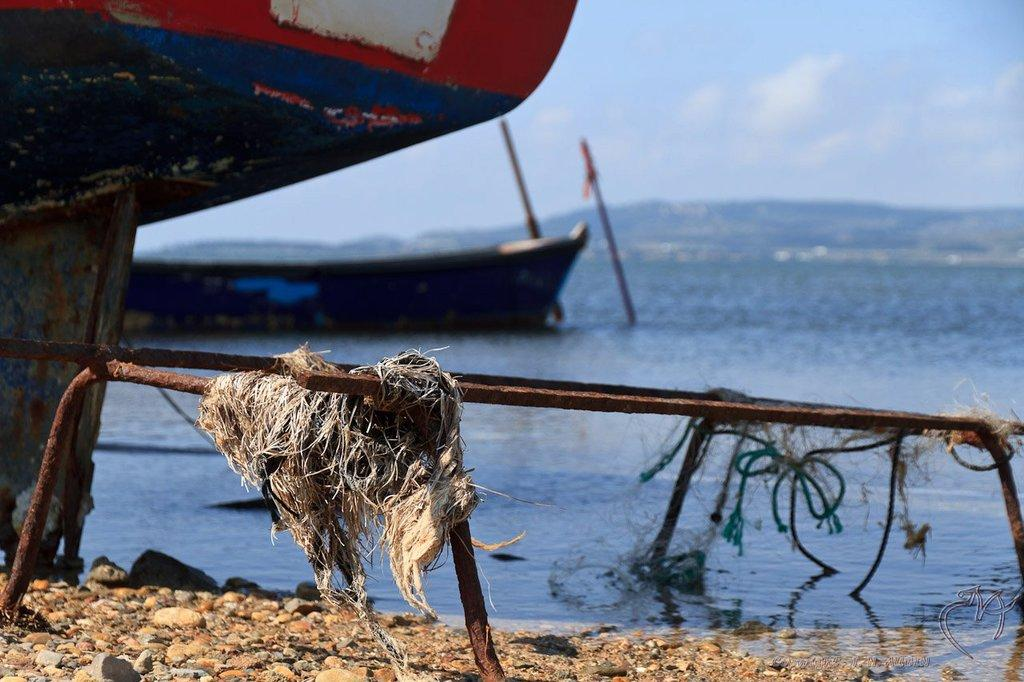What type of surface is visible in the image? There are roads on the surface in the image. What type of natural elements can be seen in the image? Stones are visible in the image. What is the boat's position in relation to the water in the image? The boat is above the water in the image. What other objects are present in the image? Sticks are present in the image. What can be seen in the background of the image? The sky is visible in the background of the image. What is the weather like in the image? Clouds are present in the sky, indicating that it might be a partly cloudy day. What type of light can be seen coming from the boat in the image? There is no light coming from the boat in the image. How are the stones sorted in the image? The stones are not sorted in the image; they are randomly scattered. 